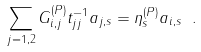Convert formula to latex. <formula><loc_0><loc_0><loc_500><loc_500>\sum _ { j = 1 , 2 } { G } _ { i , j } ^ { ( P ) } t ^ { - 1 } _ { j j } a _ { j , s } = \eta ^ { ( P ) } _ { s } a _ { i , s } \ .</formula> 